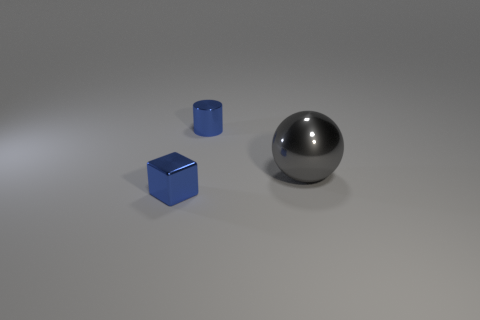Add 3 gray metal spheres. How many objects exist? 6 Subtract 0 red blocks. How many objects are left? 3 Subtract all cubes. How many objects are left? 2 Subtract all green metallic cylinders. Subtract all tiny blue metal blocks. How many objects are left? 2 Add 3 gray objects. How many gray objects are left? 4 Add 3 small blue cylinders. How many small blue cylinders exist? 4 